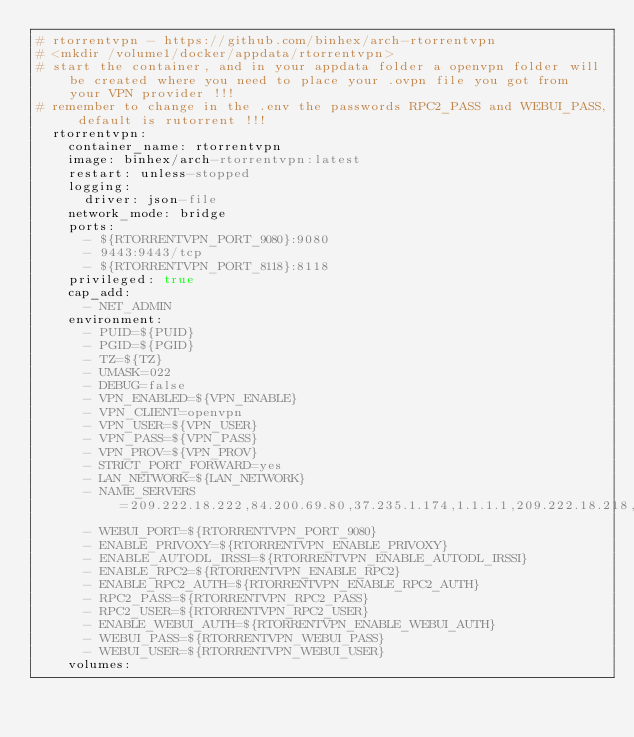<code> <loc_0><loc_0><loc_500><loc_500><_YAML_># rtorrentvpn - https://github.com/binhex/arch-rtorrentvpn
# <mkdir /volume1/docker/appdata/rtorrentvpn>
# start the container, and in your appdata folder a openvpn folder will be created where you need to place your .ovpn file you got from your VPN provider !!!
# remember to change in the .env the passwords RPC2_PASS and WEBUI_PASS, default is rutorrent !!!
  rtorrentvpn:
    container_name: rtorrentvpn
    image: binhex/arch-rtorrentvpn:latest
    restart: unless-stopped
    logging:
      driver: json-file
    network_mode: bridge
    ports:
      - ${RTORRENTVPN_PORT_9080}:9080
      - 9443:9443/tcp
      - ${RTORRENTVPN_PORT_8118}:8118
    privileged: true
    cap_add:
      - NET_ADMIN
    environment:
      - PUID=${PUID}
      - PGID=${PGID}
      - TZ=${TZ}
      - UMASK=022
      - DEBUG=false
      - VPN_ENABLED=${VPN_ENABLE}
      - VPN_CLIENT=openvpn
      - VPN_USER=${VPN_USER}
      - VPN_PASS=${VPN_PASS}
      - VPN_PROV=${VPN_PROV}
      - STRICT_PORT_FORWARD=yes
      - LAN_NETWORK=${LAN_NETWORK}
      - NAME_SERVERS=209.222.18.222,84.200.69.80,37.235.1.174,1.1.1.1,209.222.18.218,37.235.1.177,84.200.70.40,1.0.0.1
      - WEBUI_PORT=${RTORRENTVPN_PORT_9080}
      - ENABLE_PRIVOXY=${RTORRENTVPN_ENABLE_PRIVOXY}
      - ENABLE_AUTODL_IRSSI=${RTORRENTVPN_ENABLE_AUTODL_IRSSI}
      - ENABLE_RPC2=${RTORRENTVPN_ENABLE_RPC2}
      - ENABLE_RPC2_AUTH=${RTORRENTVPN_ENABLE_RPC2_AUTH}
      - RPC2_PASS=${RTORRENTVPN_RPC2_PASS}
      - RPC2_USER=${RTORRENTVPN_RPC2_USER}
      - ENABLE_WEBUI_AUTH=${RTORRENTVPN_ENABLE_WEBUI_AUTH}
      - WEBUI_PASS=${RTORRENTVPN_WEBUI_PASS}
      - WEBUI_USER=${RTORRENTVPN_WEBUI_USER}
    volumes:</code> 